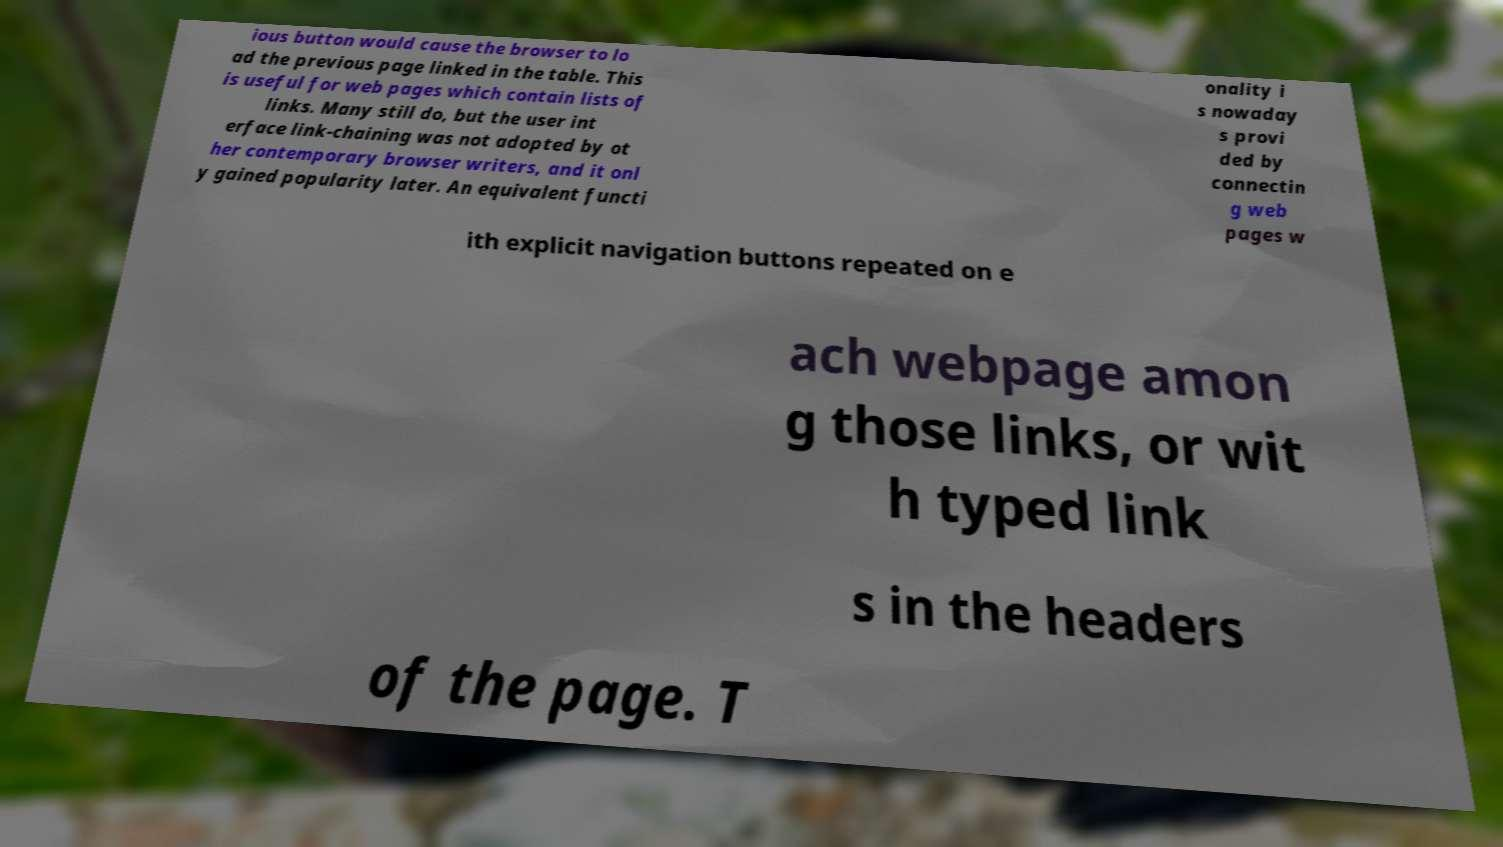Can you accurately transcribe the text from the provided image for me? ious button would cause the browser to lo ad the previous page linked in the table. This is useful for web pages which contain lists of links. Many still do, but the user int erface link-chaining was not adopted by ot her contemporary browser writers, and it onl y gained popularity later. An equivalent functi onality i s nowaday s provi ded by connectin g web pages w ith explicit navigation buttons repeated on e ach webpage amon g those links, or wit h typed link s in the headers of the page. T 